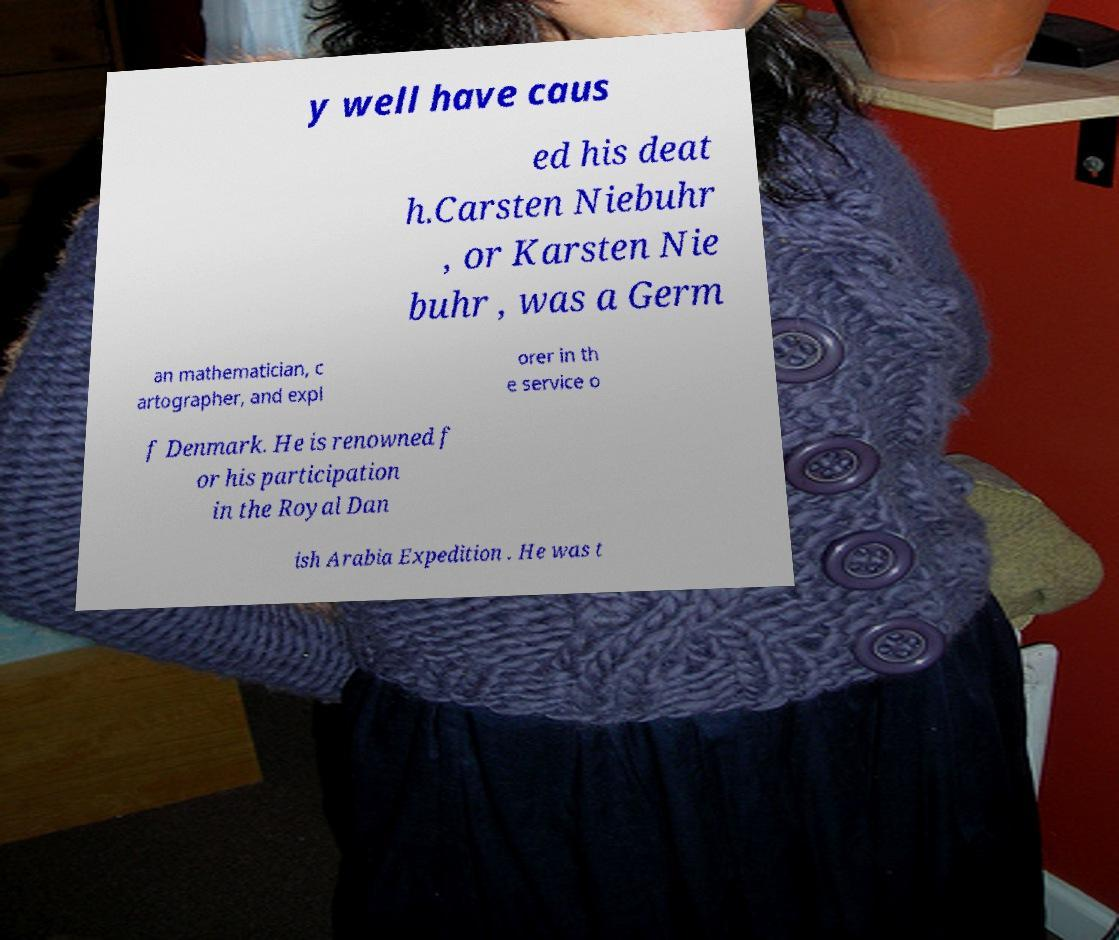Please read and relay the text visible in this image. What does it say? y well have caus ed his deat h.Carsten Niebuhr , or Karsten Nie buhr , was a Germ an mathematician, c artographer, and expl orer in th e service o f Denmark. He is renowned f or his participation in the Royal Dan ish Arabia Expedition . He was t 